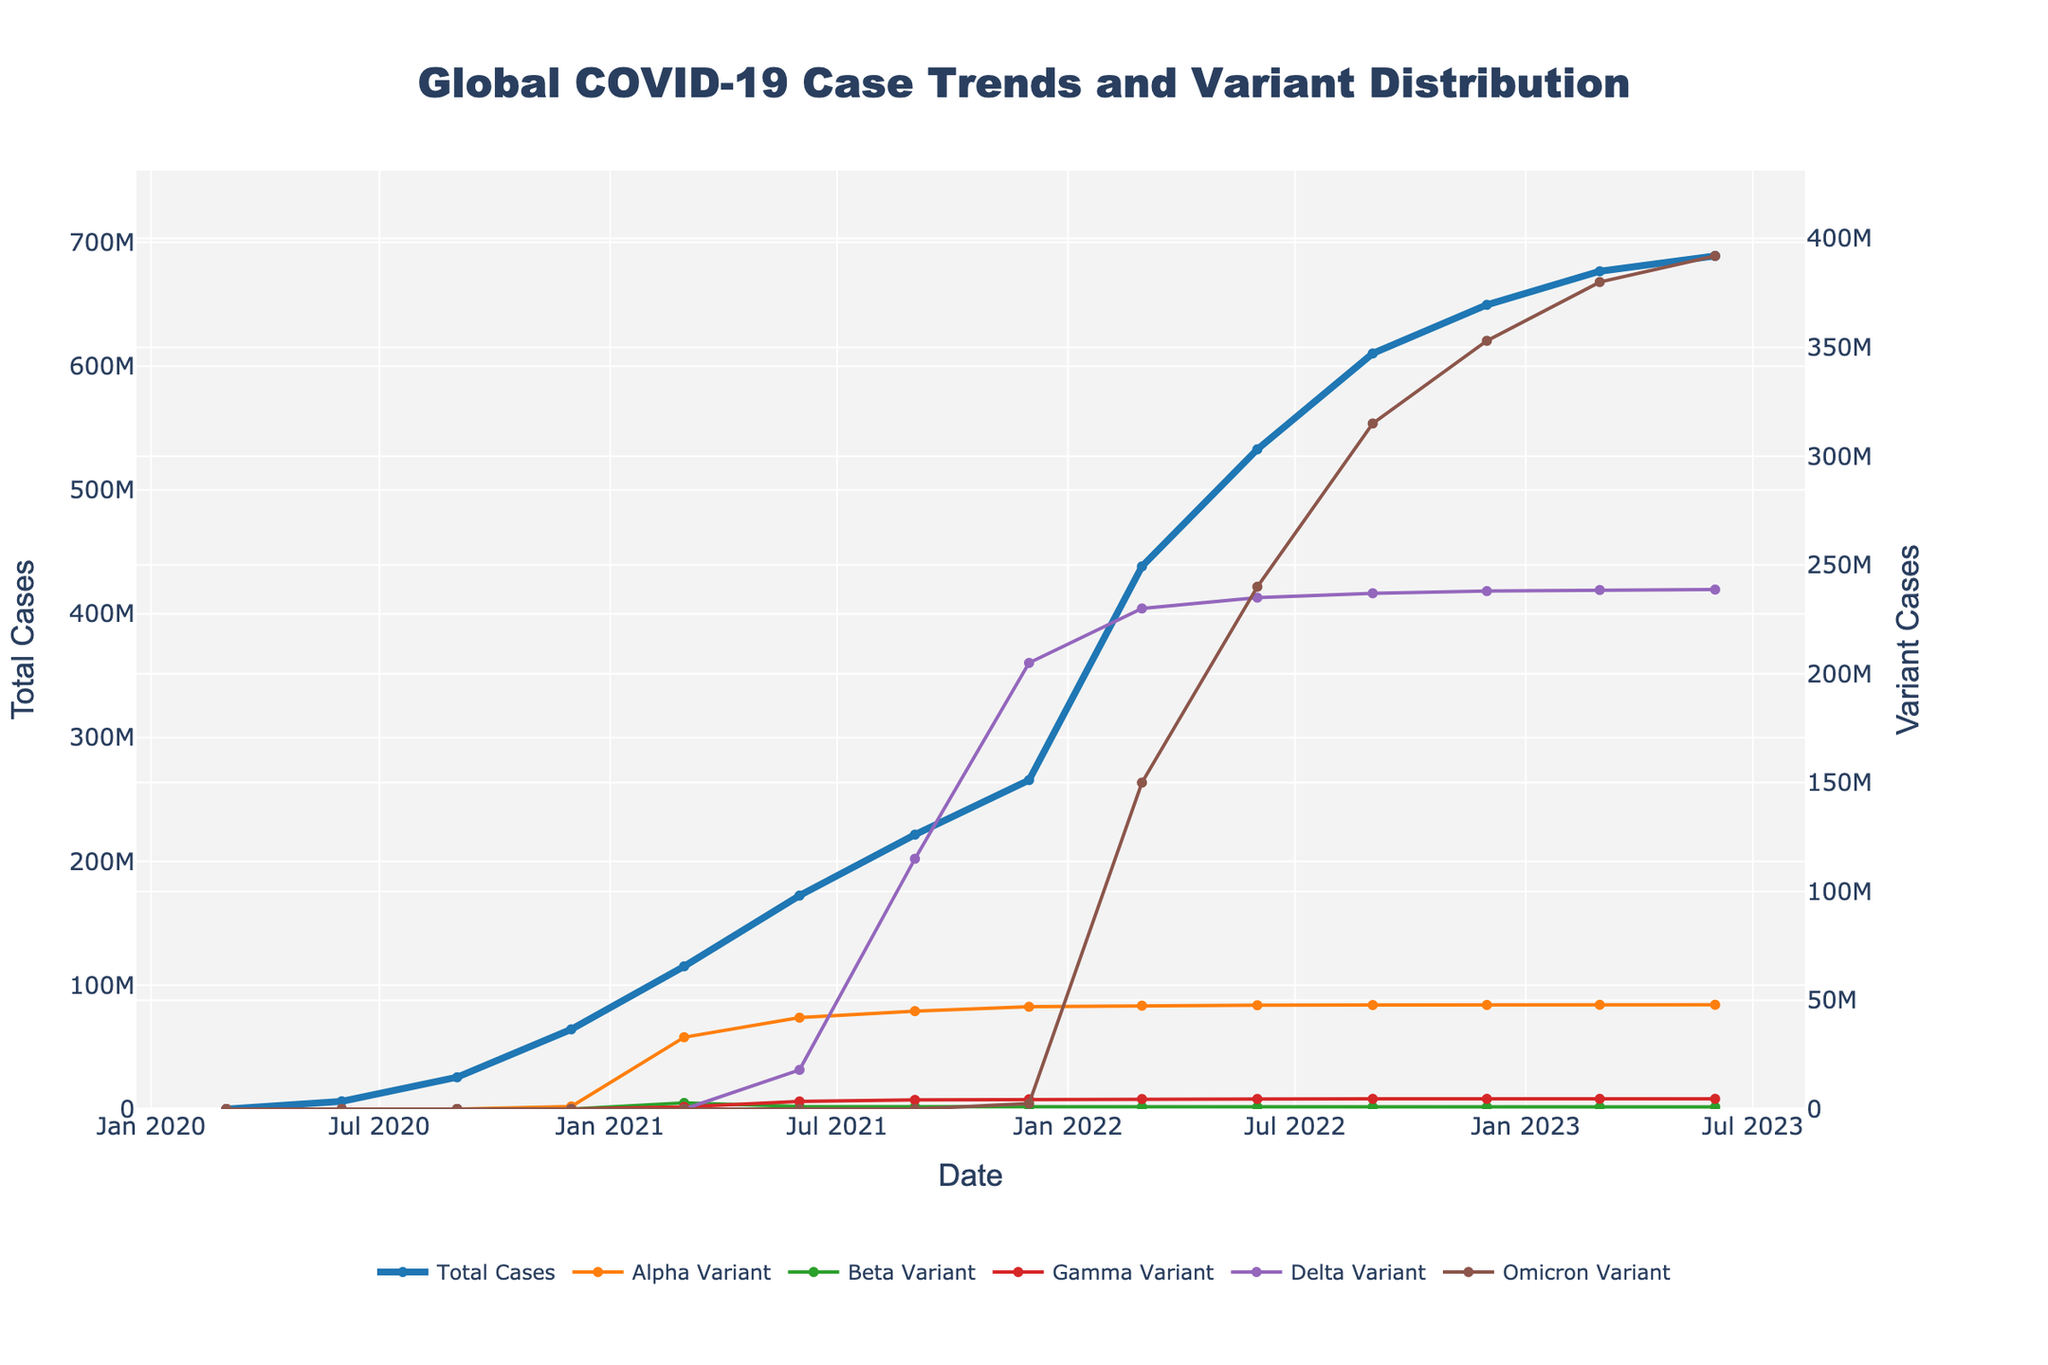What's the highest number of total COVID-19 cases reported and when? The highest number of total cases can be observed at the last data point on the x-axis and the corresponding y-axis value. Here, the final point shows around 689 million cases on June 1, 2023.
Answer: 689 million, June 1, 2023 Which variant had the most cases by March 1, 2022? By finding the point for March 1, 2022 on the x-axis, we compare the heights of the lines for each variant. Omicron has the highest value among the variants around this date.
Answer: Omicron How many cases were attributed to the Delta variant by December 1, 2021? Locate December 1, 2021, on the x-axis and follow upwards to where the Delta variant line (purple) intersects. The Delta variant shows about 205 million cases at that point.
Answer: 205 million Compare the increase in total cases between March 1, 2021, and March 1, 2022. How significant is the increase? Subtract the total cases in March 2021 (approximately 115 million) from those in March 2022 (approximately 438 million). The difference is about 323 million, indicating a significant increase.
Answer: 323 million What visual differences can you observe between the trends for Alpha and Omicron variants? The Alpha variant line is shorter and plateaus earlier, whereas the Omicron line rises steeply and reaches higher values, showing a more substantial and rapid spread.
Answer: Omicron rises more steeply and higher Sum the cases reported for the Beta and Gamma variants by September 1, 2022. Observe the intersection points for Beta (approximately 970,000) and Gamma (approximately 4.68 million) on September 1, 2022, and add them together. 970,000 + 4.68 million = approximately 5.65 million.
Answer: 5.65 million How did the total number of COVID-19 cases change from December 1, 2021, to June 1, 2022? Find the total cases for December 1, 2021 (approximately 266 million) and June 1, 2022 (approximately 533 million). Subtracting the former from the latter gives an increase of about 267 million cases.
Answer: 267 million Which variant had the smallest increase in cases between December 1, 2021, and December 1, 2022? Identify the values for each variant on both dates and compare. Gamma had an increase from about 4.5 million to around 4.69 million, which is the smallest change.
Answer: Gamma 